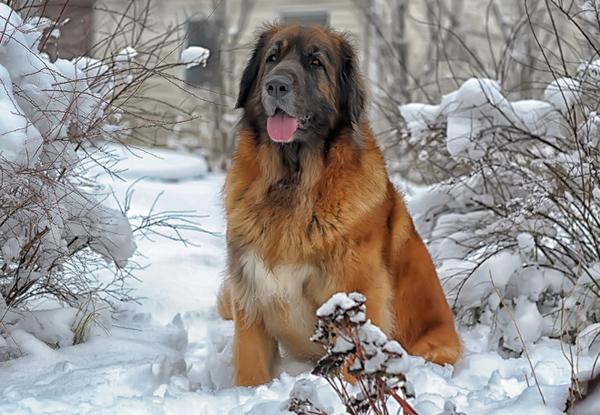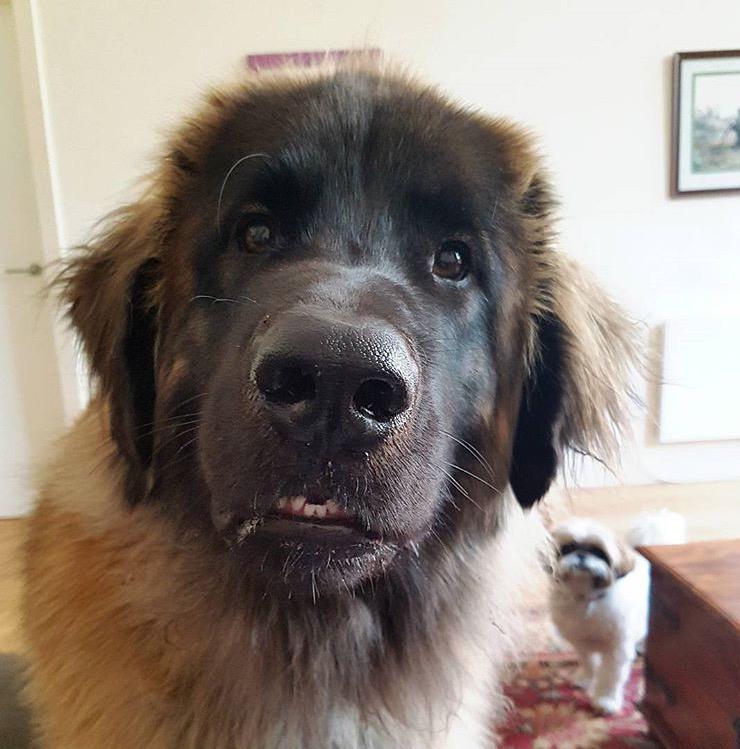The first image is the image on the left, the second image is the image on the right. Analyze the images presented: Is the assertion "In one image a dog is outdoors with its tongue showing." valid? Answer yes or no. Yes. 